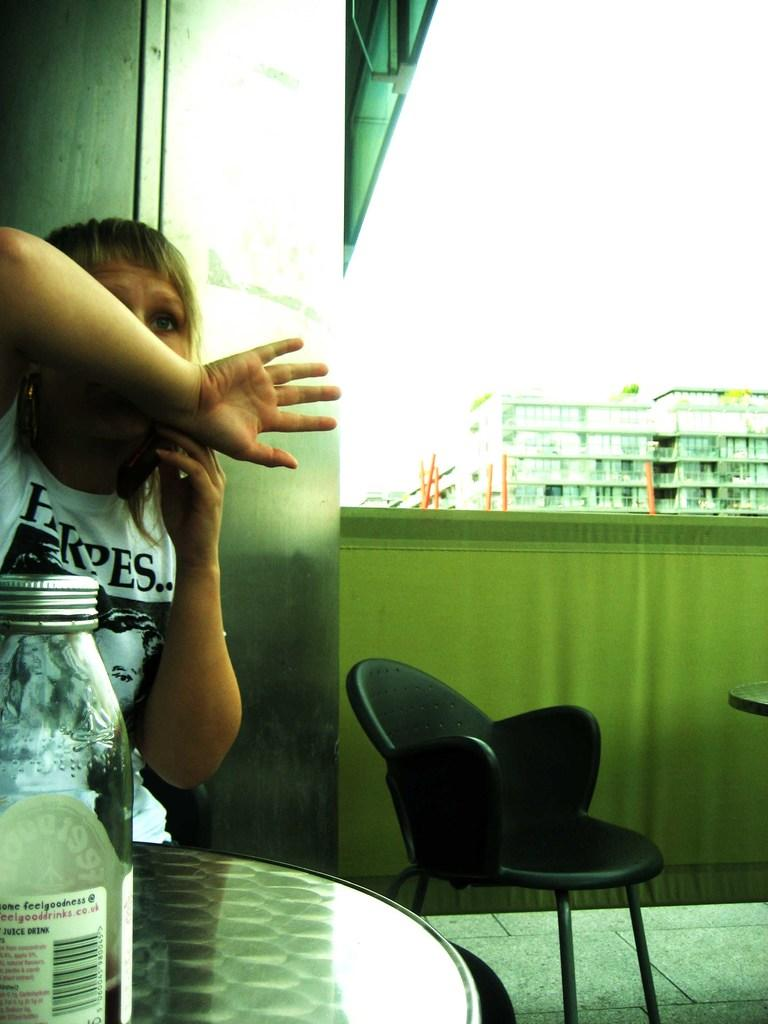Who is present in the image? There is a woman in the image. What is the woman doing in the image? The woman is seated. What object can be seen on the table in the image? There is a bottle on the table. What can be seen in the background of the image? There are buildings visible in the background of the image. How many toes are visible in the image? There are no toes visible in the image, as it features a woman seated with her feet likely hidden from view. 